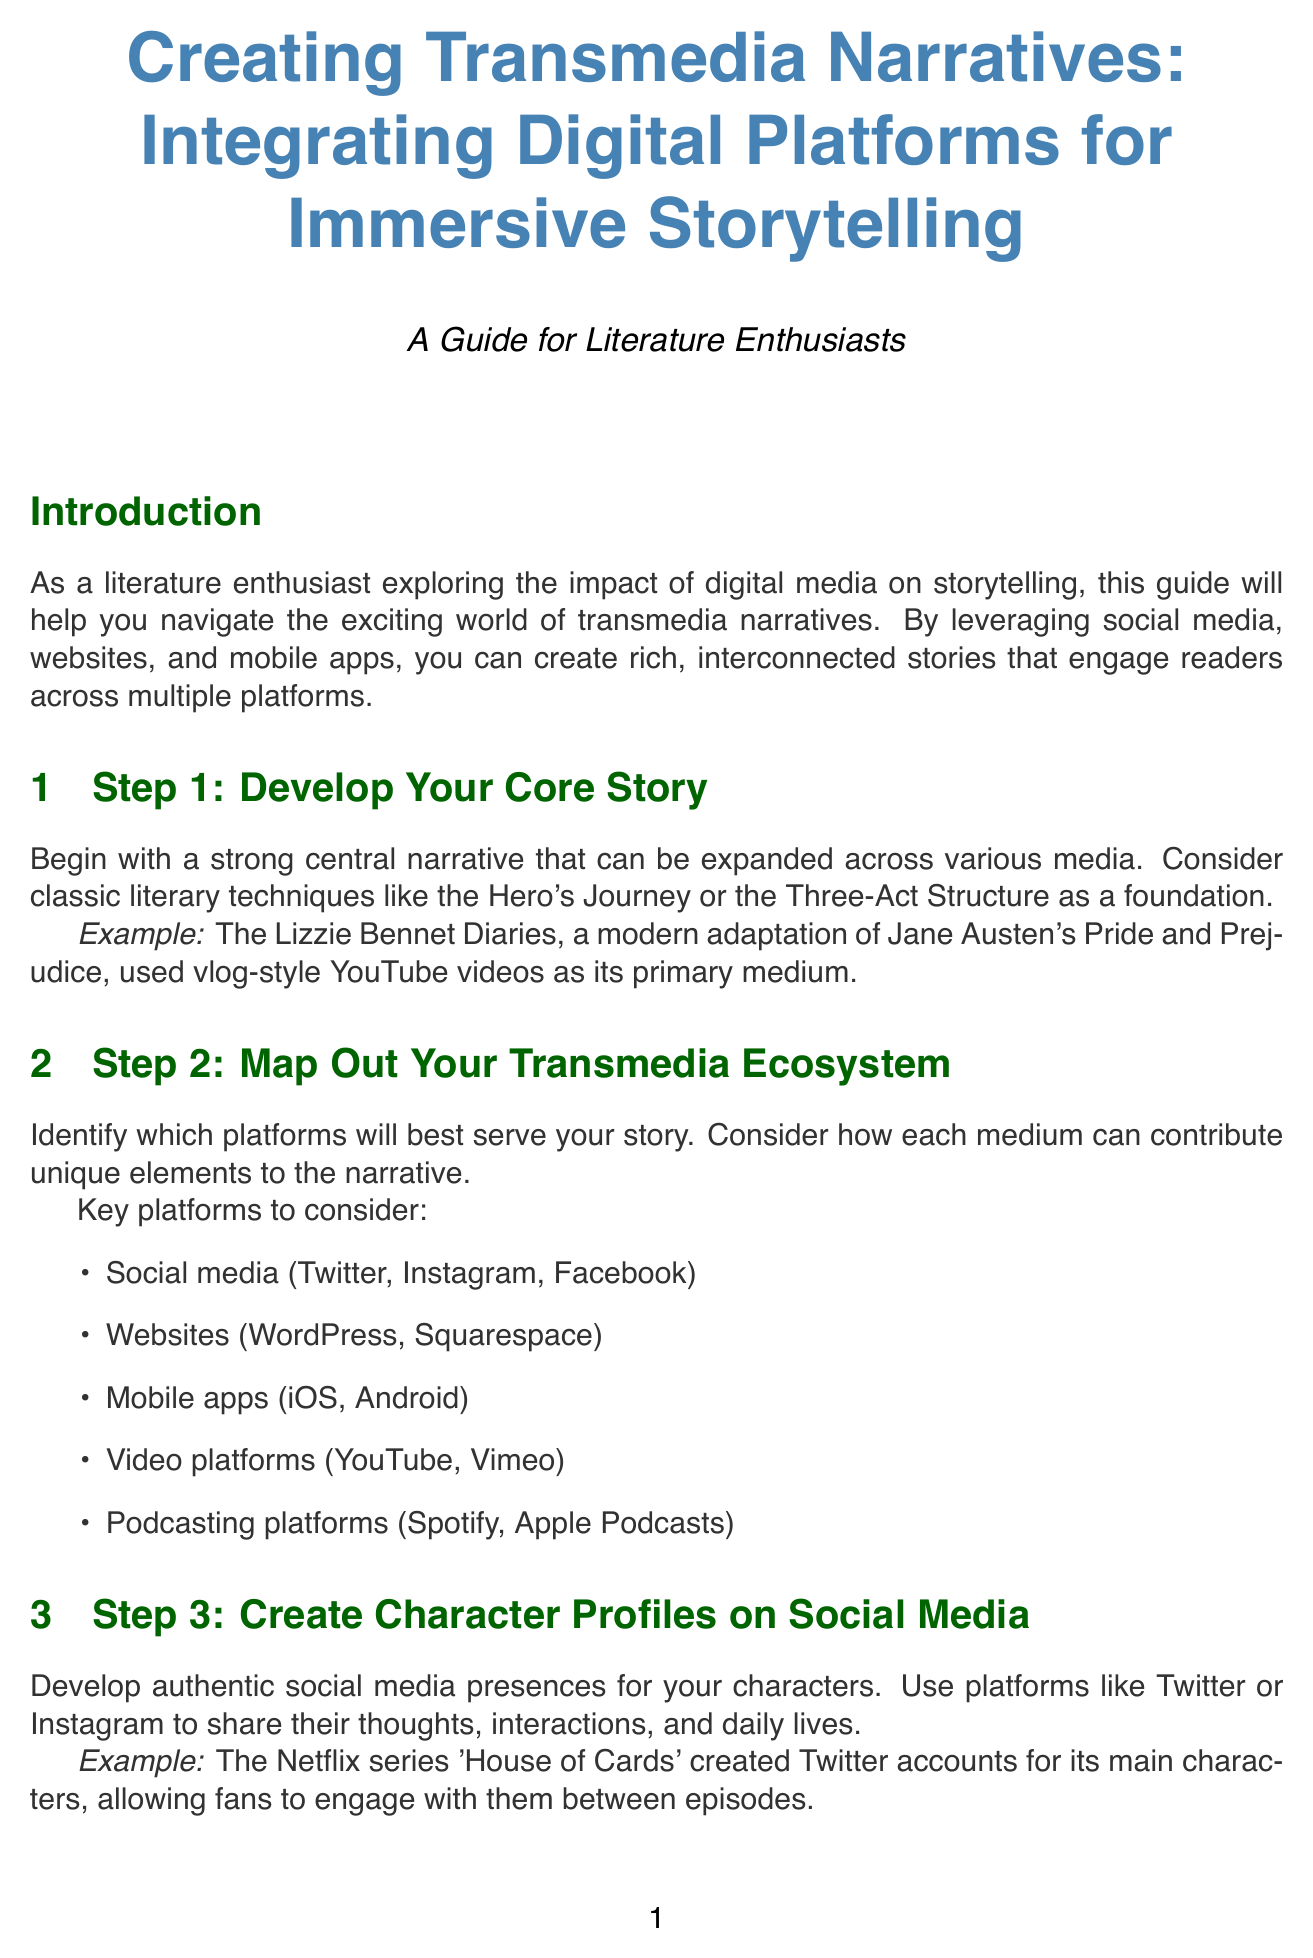What is the title of the manual? The title of the document is prominently displayed at the beginning, which is "Creating Transmedia Narratives: Integrating Digital Platforms for Immersive Storytelling."
Answer: Creating Transmedia Narratives: Integrating Digital Platforms for Immersive Storytelling How many steps are outlined in the tutorial? The document lists eight distinct steps for creating transmedia narratives.
Answer: 8 What example is given for a core story? The document provides an example of "The Lizzie Bennet Diaries" for illustrating a core story in a transmedia narrative.
Answer: The Lizzie Bennet Diaries Which social media platforms are suggested for creating character profiles? The document mentions Twitter and Instagram as platforms for developing character profiles.
Answer: Twitter, Instagram What should be included in the immersive website? The document lists various elements to include, with "character bios" as one of the features mentioned.
Answer: Character bios What is the purpose of a mobile app in transmedia storytelling? The document states the mobile app should complement the story, serving various interactive purposes, such as a game.
Answer: Complement the story Which tool is recommended for analyzing user engagement? Google Analytics is mentioned as a tool for analyzing user engagement with the story in the document.
Answer: Google Analytics What technique is suggested for managing content across platforms? The document advises creating a content calendar to effectively coordinate story elements across all platforms.
Answer: Content calendar 